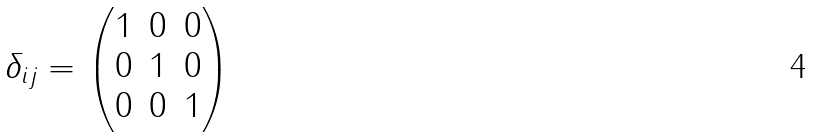Convert formula to latex. <formula><loc_0><loc_0><loc_500><loc_500>\delta _ { i j } = \begin{pmatrix} 1 & 0 & 0 \\ 0 & 1 & 0 \\ 0 & 0 & 1 \end{pmatrix}</formula> 